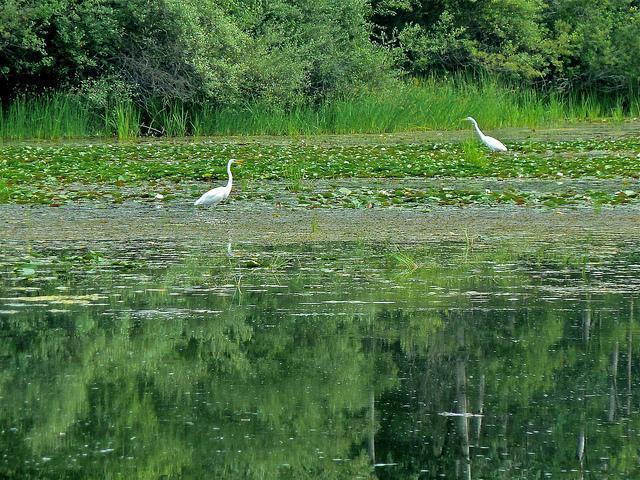How many ski poles is this person holding?
Give a very brief answer. 0. 